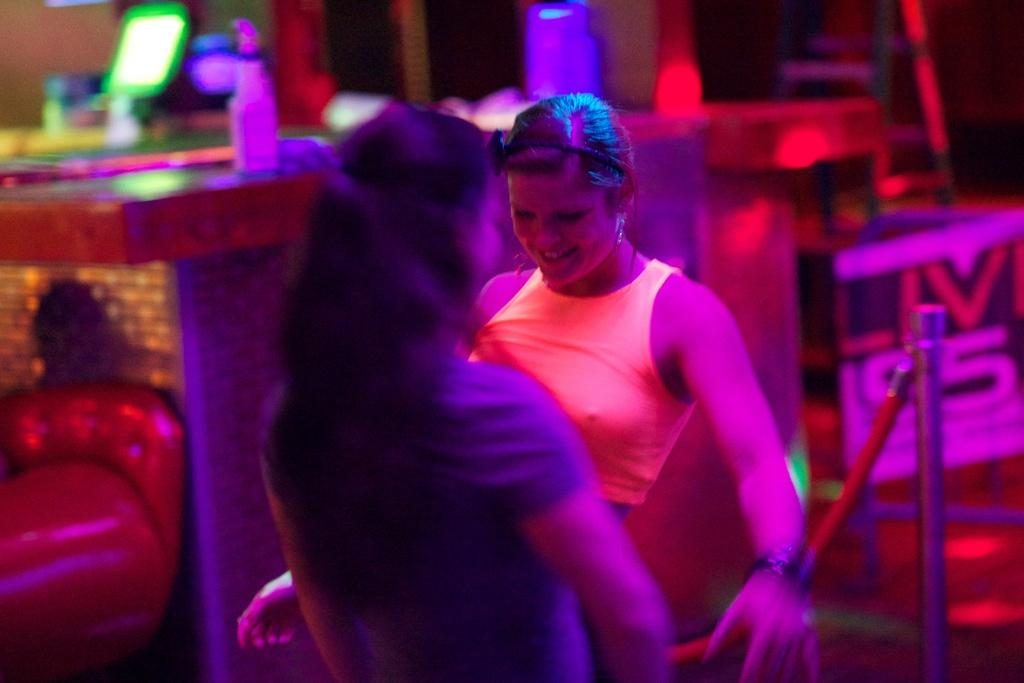How many people are in the image? There are two women in the image. What is the facial expression of the women? The women are smiling. Can you describe any objects or features in the background of the image? There appears to be a mirror in the top left corner of the image. What type of hill can be seen in the background of the image? There is no hill visible in the image; it only features two women and a mirror. What is the grandmother's favorite type of fabric in the image? There is no grandmother or fabric present in the image. 